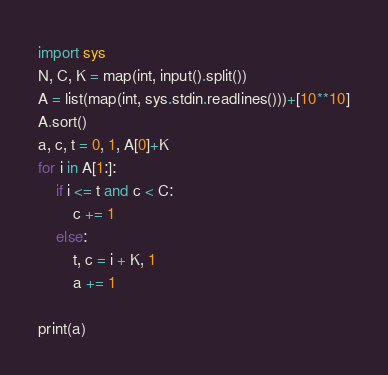Convert code to text. <code><loc_0><loc_0><loc_500><loc_500><_Python_>import sys
N, C, K = map(int, input().split())
A = list(map(int, sys.stdin.readlines()))+[10**10]
A.sort()
a, c, t = 0, 1, A[0]+K
for i in A[1:]:
    if i <= t and c < C:
        c += 1
    else:
        t, c = i + K, 1
        a += 1
 
print(a)</code> 